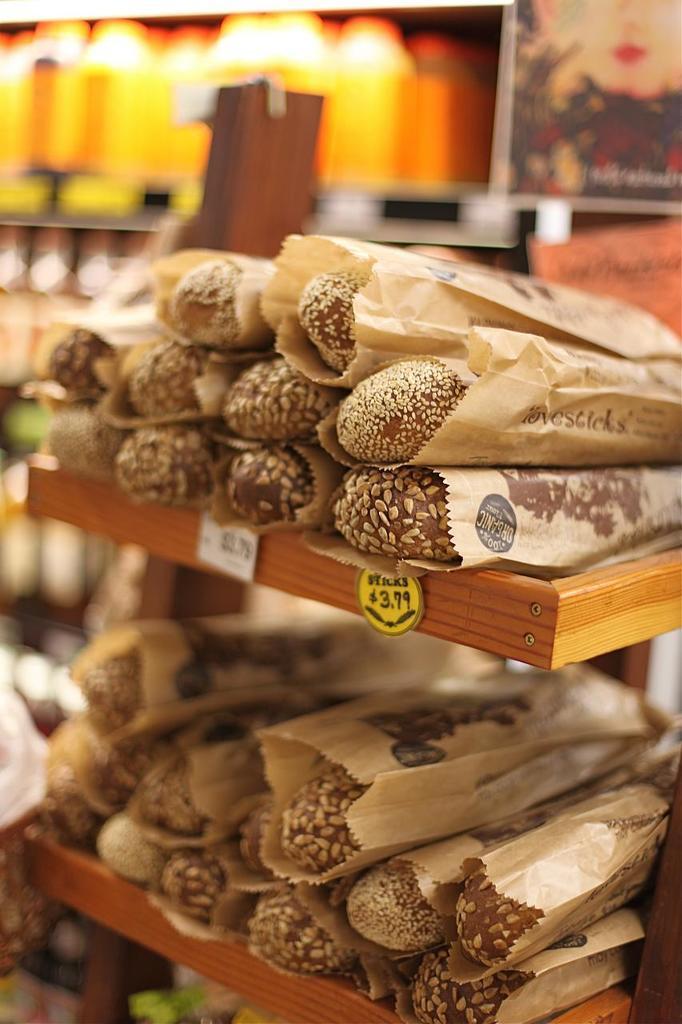Please provide a concise description of this image. In front of the image there are food items on the rack with the name tags. There is a photo frame and the background of the image is blur. 